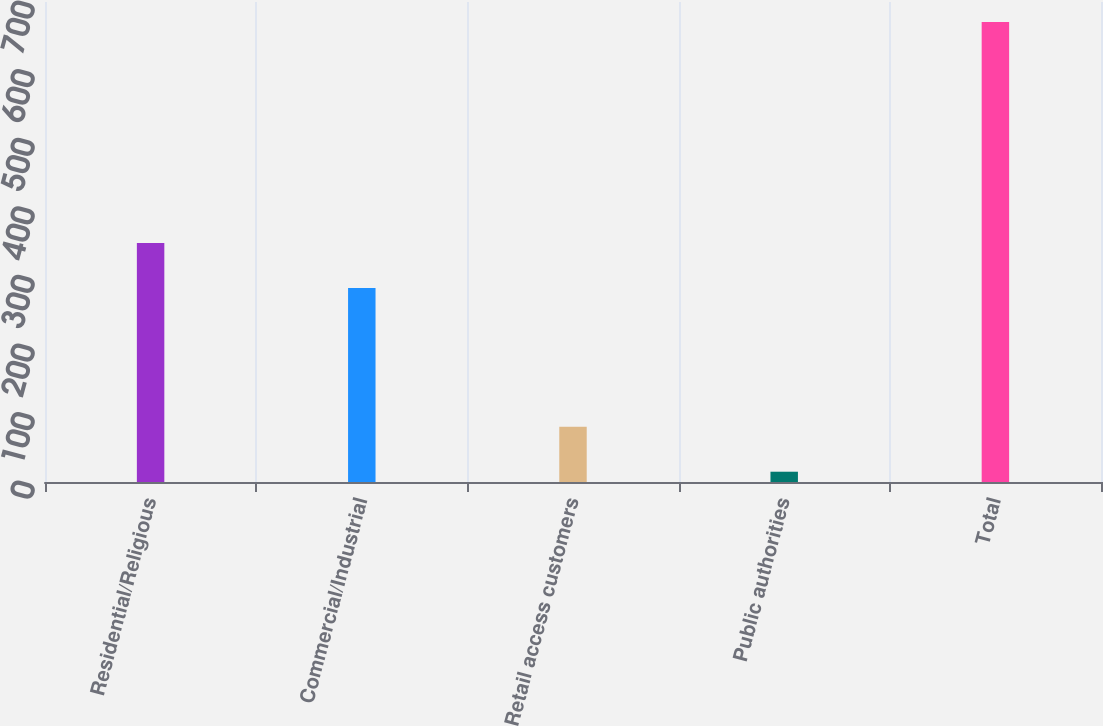Convert chart to OTSL. <chart><loc_0><loc_0><loc_500><loc_500><bar_chart><fcel>Residential/Religious<fcel>Commercial/Industrial<fcel>Retail access customers<fcel>Public authorities<fcel>Total<nl><fcel>348.6<fcel>283<fcel>80.6<fcel>15<fcel>671<nl></chart> 